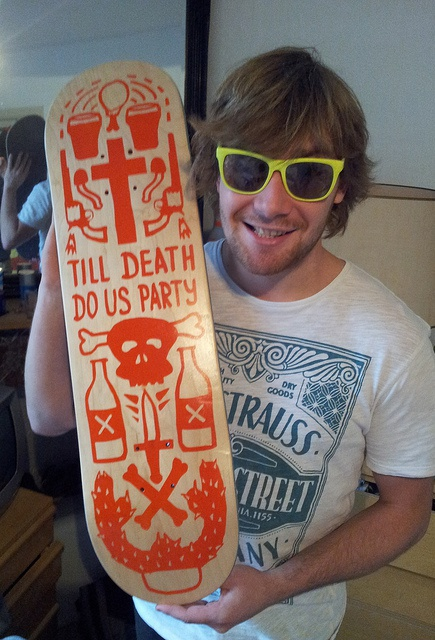Describe the objects in this image and their specific colors. I can see people in darkgray, gray, black, and brown tones, skateboard in darkgray, brown, tan, and red tones, and people in darkgray, black, gray, and lightblue tones in this image. 